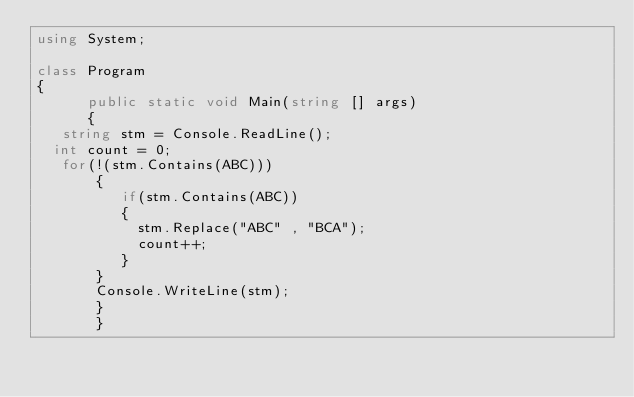<code> <loc_0><loc_0><loc_500><loc_500><_C#_>using System;

class Program
{
      public static void Main(string [] args)
      {
   string stm = Console.ReadLine();
  int count = 0;
   for(!(stm.Contains(ABC)))
       {
          if(stm.Contains(ABC))
          {
            stm.Replace("ABC" , "BCA");
            count++;
          }
       }
       Console.WriteLine(stm);
       }
       }
</code> 